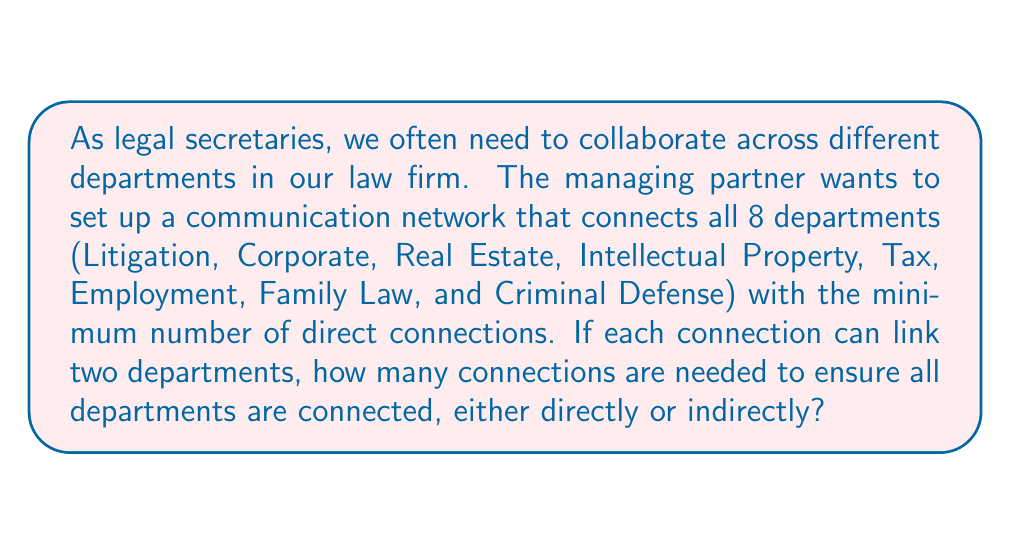Give your solution to this math problem. This problem can be solved using the concept of a minimum spanning tree in graph theory. Here's how we can approach it:

1. First, we need to understand that the departments represent nodes in a graph, and the connections represent edges.

2. The minimum number of connections needed to link all departments is equal to the number of edges in a minimum spanning tree of the graph.

3. For any connected graph with $n$ nodes, the minimum spanning tree always has exactly $n-1$ edges.

4. In this case, we have 8 departments, so $n = 8$.

5. Therefore, the minimum number of connections needed is:

   $$\text{Number of connections} = n - 1 = 8 - 1 = 7$$

This solution ensures that all departments are connected, either directly or through other departments, with the minimum number of connections possible.

[asy]
unitsize(30);
pair[] nodes = {(0,0), (1,1), (2,0), (3,1), (4,0), (2,2), (0,2), (4,2)};
for(int i = 0; i < 8; ++i) {
  dot(nodes[i]);
}
draw(nodes[0]--nodes[1]--nodes[2]--nodes[3]--nodes[4]);
draw(nodes[2]--nodes[5]);
draw(nodes[5]--nodes[6]);
draw(nodes[5]--nodes[7]);
label("Minimum Spanning Tree", (2,-0.5), S);
[/asy]

The diagram above illustrates a possible minimum spanning tree for the 8 departments, showing how 7 connections can link all departments.
Answer: $7$ connections 